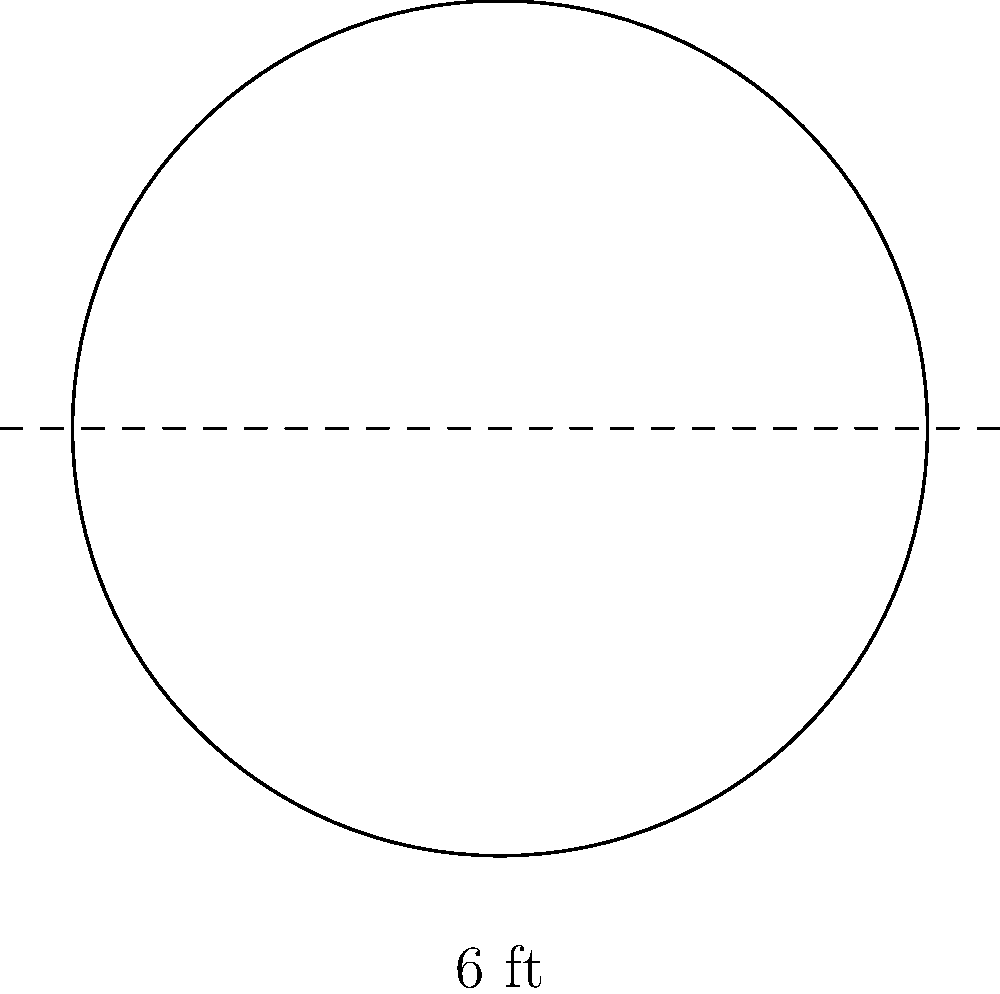You've recently purchased a new circular table for your bar. The table has a diameter of 6 feet. What is the area of the table's surface in square feet? Round your answer to two decimal places. To find the area of a circular table, we need to follow these steps:

1. Recall the formula for the area of a circle: $A = \pi r^2$, where $A$ is the area and $r$ is the radius.

2. We are given the diameter, which is 6 feet. The radius is half of the diameter:
   $r = \frac{diameter}{2} = \frac{6}{2} = 3$ feet

3. Now, let's substitute this into our formula:
   $A = \pi r^2 = \pi (3)^2 = 9\pi$ square feet

4. Using $\pi \approx 3.14159$, we can calculate:
   $A \approx 9 \times 3.14159 = 28.27431$ square feet

5. Rounding to two decimal places:
   $A \approx 28.27$ square feet

Therefore, the area of the circular bar table is approximately 28.27 square feet.
Answer: 28.27 sq ft 